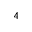<formula> <loc_0><loc_0><loc_500><loc_500>^ { 4 }</formula> 